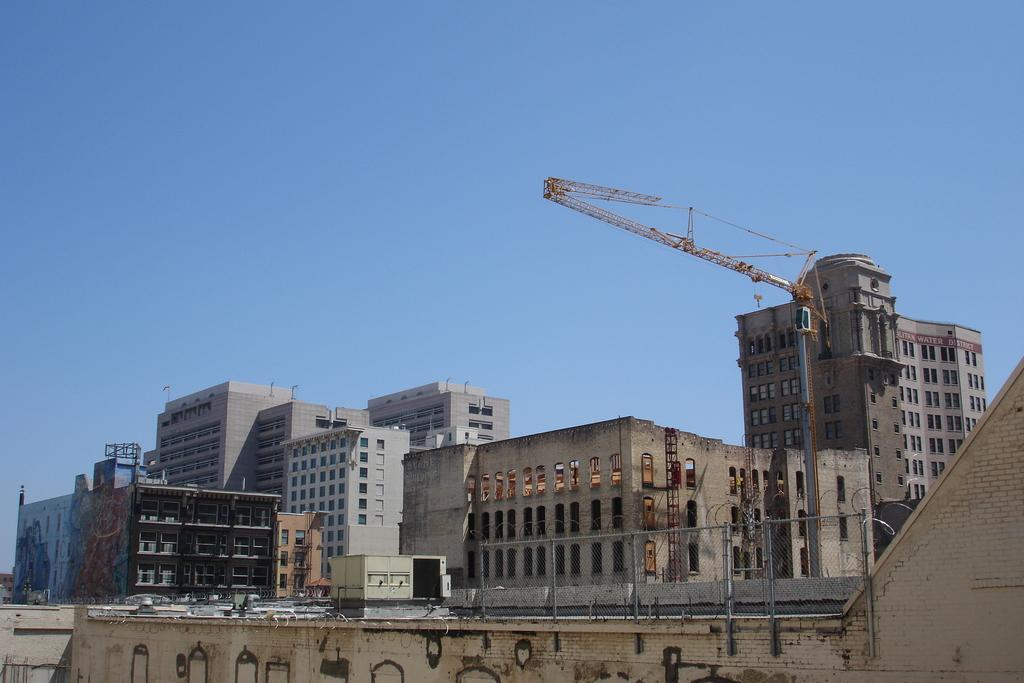What type of structures are located in the middle of the image? There are big buildings in the middle of the image. What can be seen on the right side of the image? There is a crane on the right side of the image. What is visible at the top of the image? The sky is visible at the top of the image. Can you describe the smell of the drawer in the image? There is no drawer present in the image, so it is not possible to describe its smell. 